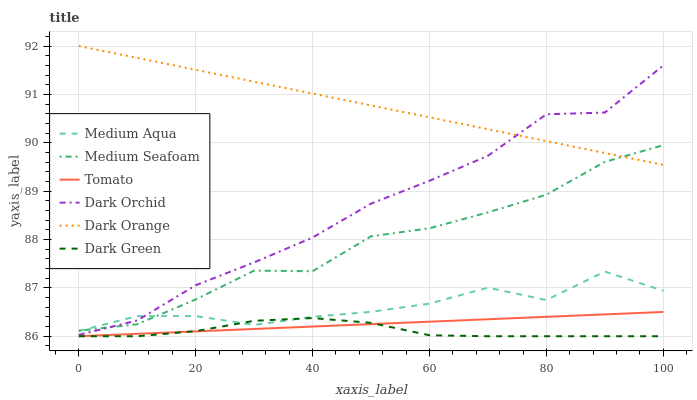Does Dark Green have the minimum area under the curve?
Answer yes or no. Yes. Does Dark Orange have the maximum area under the curve?
Answer yes or no. Yes. Does Dark Orchid have the minimum area under the curve?
Answer yes or no. No. Does Dark Orchid have the maximum area under the curve?
Answer yes or no. No. Is Dark Orange the smoothest?
Answer yes or no. Yes. Is Medium Aqua the roughest?
Answer yes or no. Yes. Is Dark Orchid the smoothest?
Answer yes or no. No. Is Dark Orchid the roughest?
Answer yes or no. No. Does Tomato have the lowest value?
Answer yes or no. Yes. Does Dark Orchid have the lowest value?
Answer yes or no. No. Does Dark Orange have the highest value?
Answer yes or no. Yes. Does Dark Orchid have the highest value?
Answer yes or no. No. Is Medium Aqua less than Dark Orange?
Answer yes or no. Yes. Is Dark Orange greater than Medium Aqua?
Answer yes or no. Yes. Does Medium Aqua intersect Dark Green?
Answer yes or no. Yes. Is Medium Aqua less than Dark Green?
Answer yes or no. No. Is Medium Aqua greater than Dark Green?
Answer yes or no. No. Does Medium Aqua intersect Dark Orange?
Answer yes or no. No. 